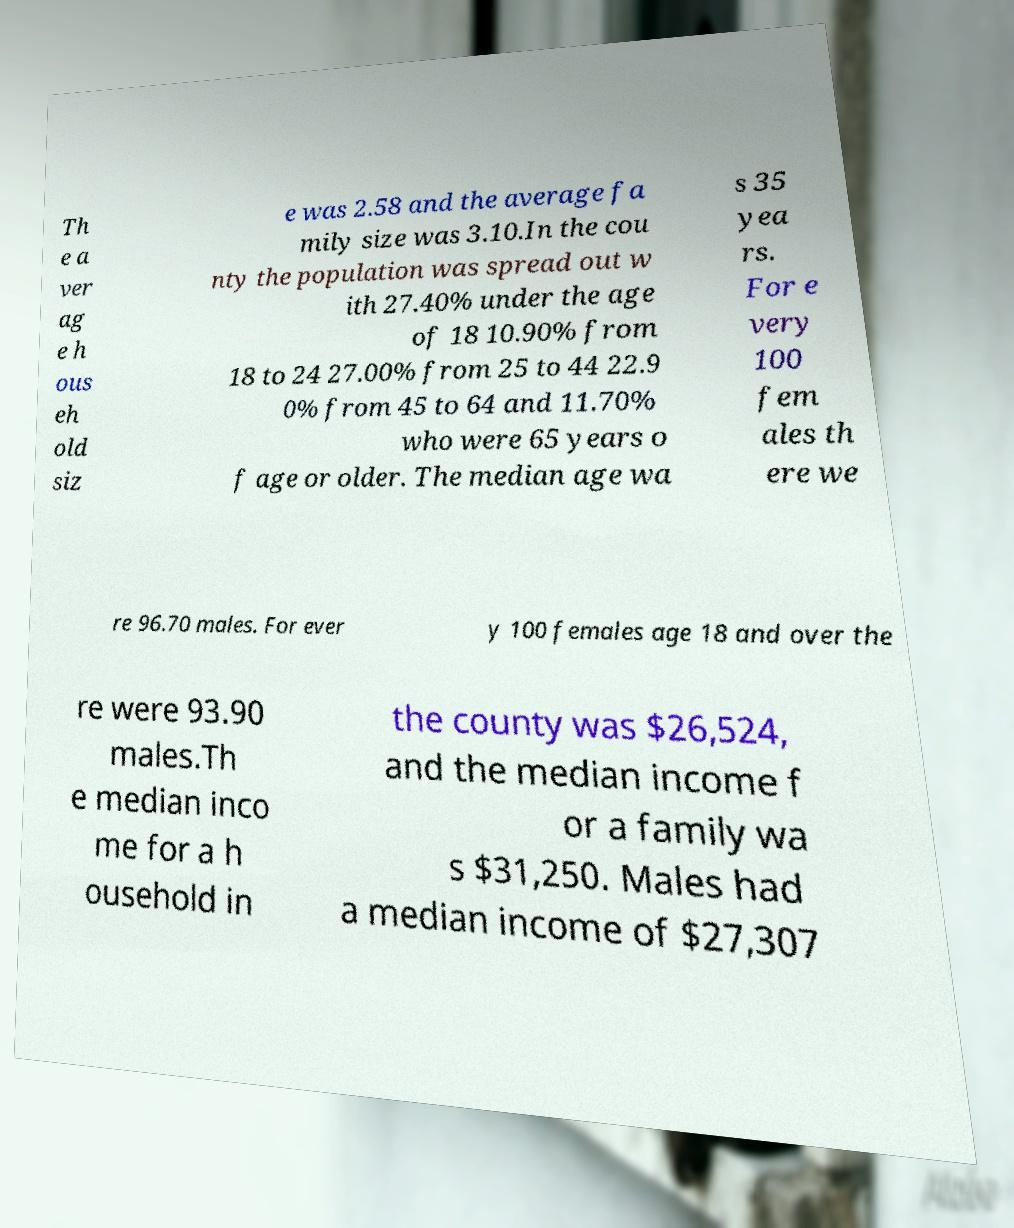Could you assist in decoding the text presented in this image and type it out clearly? Th e a ver ag e h ous eh old siz e was 2.58 and the average fa mily size was 3.10.In the cou nty the population was spread out w ith 27.40% under the age of 18 10.90% from 18 to 24 27.00% from 25 to 44 22.9 0% from 45 to 64 and 11.70% who were 65 years o f age or older. The median age wa s 35 yea rs. For e very 100 fem ales th ere we re 96.70 males. For ever y 100 females age 18 and over the re were 93.90 males.Th e median inco me for a h ousehold in the county was $26,524, and the median income f or a family wa s $31,250. Males had a median income of $27,307 